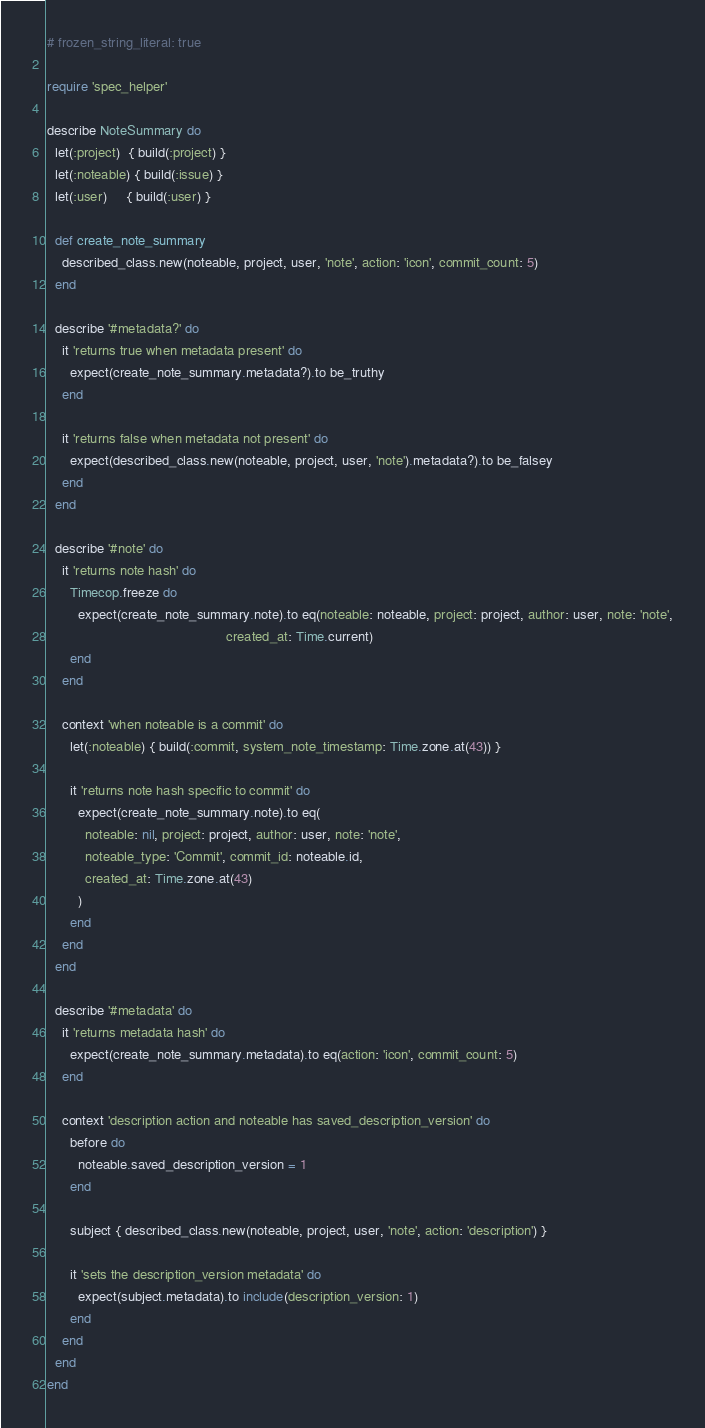<code> <loc_0><loc_0><loc_500><loc_500><_Ruby_># frozen_string_literal: true

require 'spec_helper'

describe NoteSummary do
  let(:project)  { build(:project) }
  let(:noteable) { build(:issue) }
  let(:user)     { build(:user) }

  def create_note_summary
    described_class.new(noteable, project, user, 'note', action: 'icon', commit_count: 5)
  end

  describe '#metadata?' do
    it 'returns true when metadata present' do
      expect(create_note_summary.metadata?).to be_truthy
    end

    it 'returns false when metadata not present' do
      expect(described_class.new(noteable, project, user, 'note').metadata?).to be_falsey
    end
  end

  describe '#note' do
    it 'returns note hash' do
      Timecop.freeze do
        expect(create_note_summary.note).to eq(noteable: noteable, project: project, author: user, note: 'note',
                                               created_at: Time.current)
      end
    end

    context 'when noteable is a commit' do
      let(:noteable) { build(:commit, system_note_timestamp: Time.zone.at(43)) }

      it 'returns note hash specific to commit' do
        expect(create_note_summary.note).to eq(
          noteable: nil, project: project, author: user, note: 'note',
          noteable_type: 'Commit', commit_id: noteable.id,
          created_at: Time.zone.at(43)
        )
      end
    end
  end

  describe '#metadata' do
    it 'returns metadata hash' do
      expect(create_note_summary.metadata).to eq(action: 'icon', commit_count: 5)
    end

    context 'description action and noteable has saved_description_version' do
      before do
        noteable.saved_description_version = 1
      end

      subject { described_class.new(noteable, project, user, 'note', action: 'description') }

      it 'sets the description_version metadata' do
        expect(subject.metadata).to include(description_version: 1)
      end
    end
  end
end
</code> 